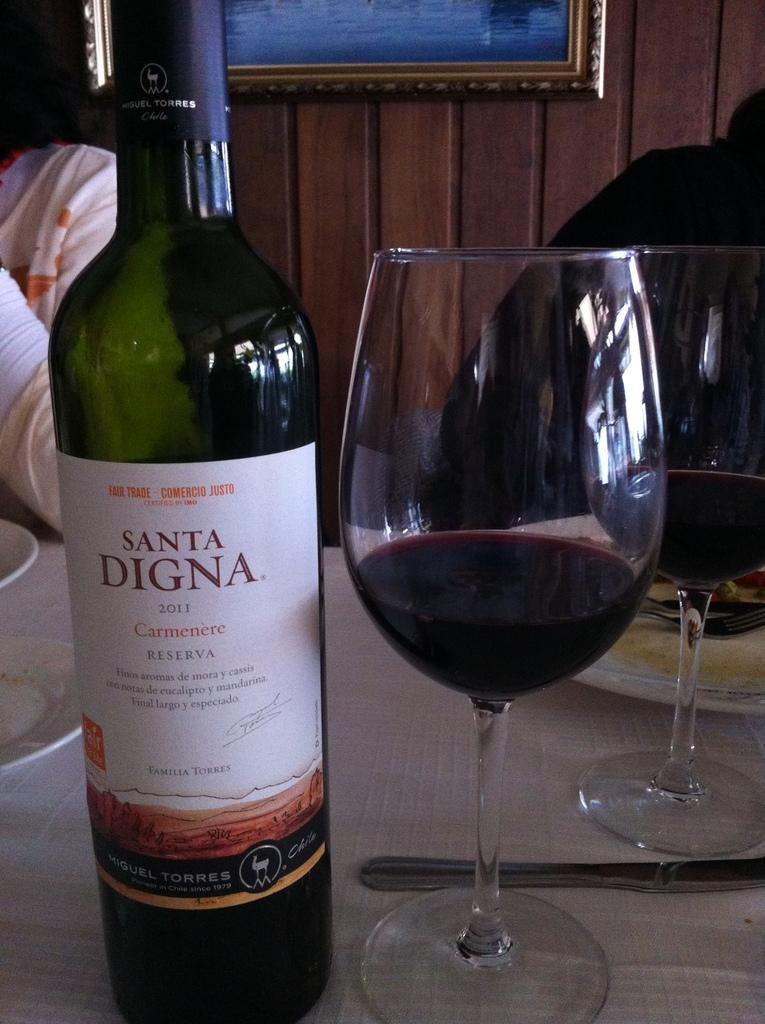Provide a one-sentence caption for the provided image. A bottle of Santa Digna 2011 Carmenere is next to a wine glass. 